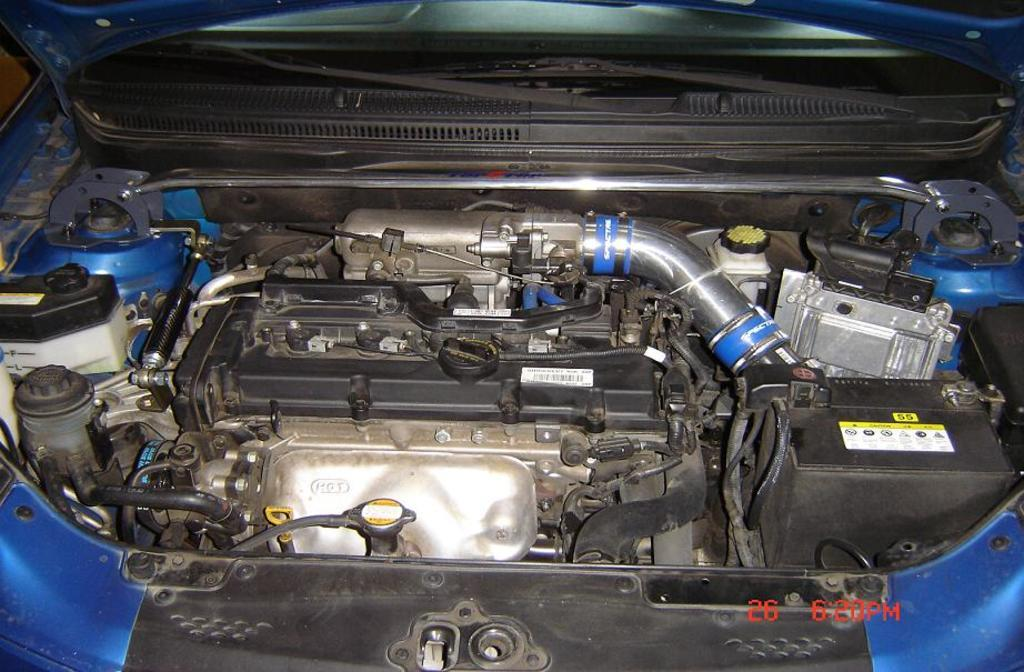What is the main subject of the image? The main subject of the image is an engine of a car. Can you describe the engine in more detail? Unfortunately, the image does not provide enough detail to describe the engine further. What type of vehicle might this engine belong to? The image does not provide enough information to determine the type of vehicle the engine belongs to. What type of tooth can be seen in the image? There is no tooth present in the image; it features an engine of a car. 